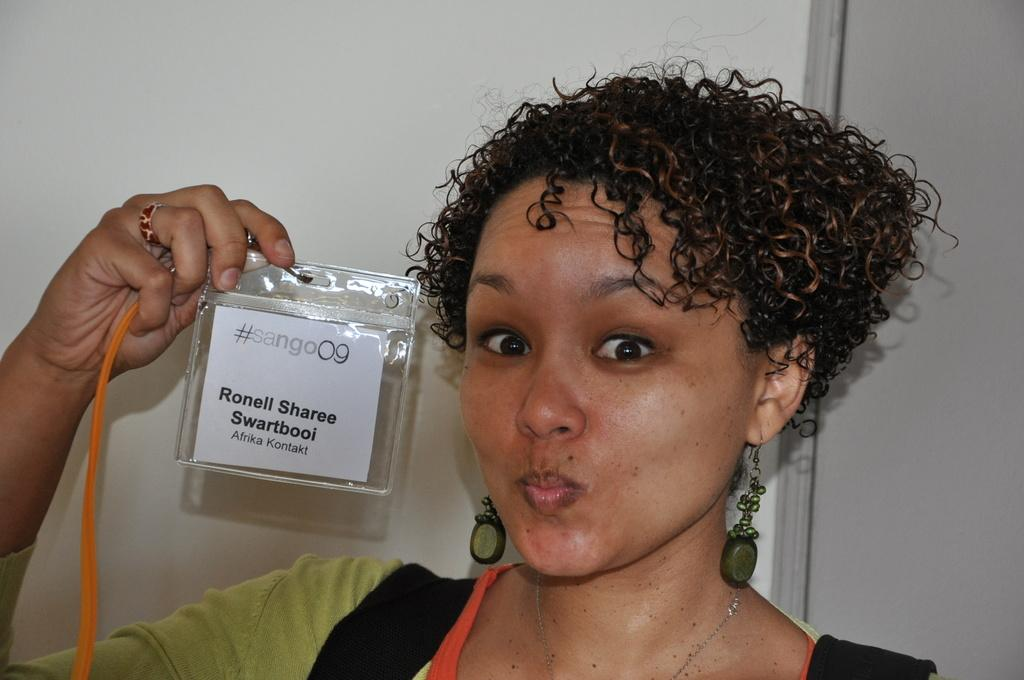Who is present in the image? There is a woman in the image. What is the woman holding in the image? The woman is holding an ID card. What is the woman wearing in the image? The woman is wearing a green dress. What can be seen in the background of the image? There is a white wall in the background of the image. What time of day is it in the image? The time of day cannot be determined from the image, as there are no clues or indications of the time. 